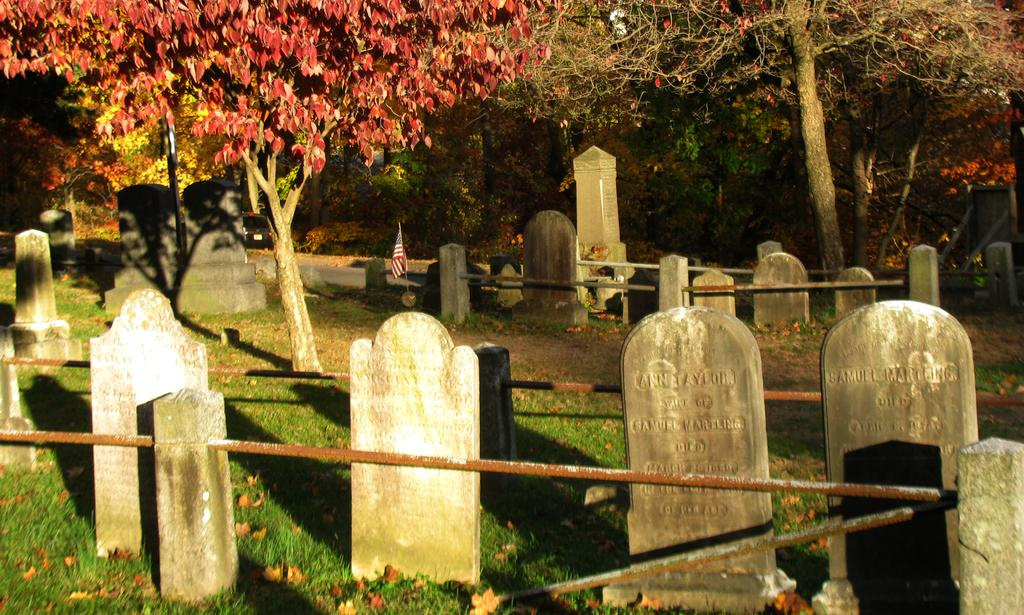What type of location is depicted in the image? The image contains cemeteries. What can be seen in the background of the image? There are trees visible in the image. What is the color of the leaves on the trees? The leaves on the trees are red. What is attached to the pole in the image? There is a flag attached to the pole in the image. How does the beam of light affect the cemeteries in the image? There is no beam of light present in the image. What type of wound is visible on the trees in the image? There are no wounds visible on the trees in the image; they have red-colored leaves. 